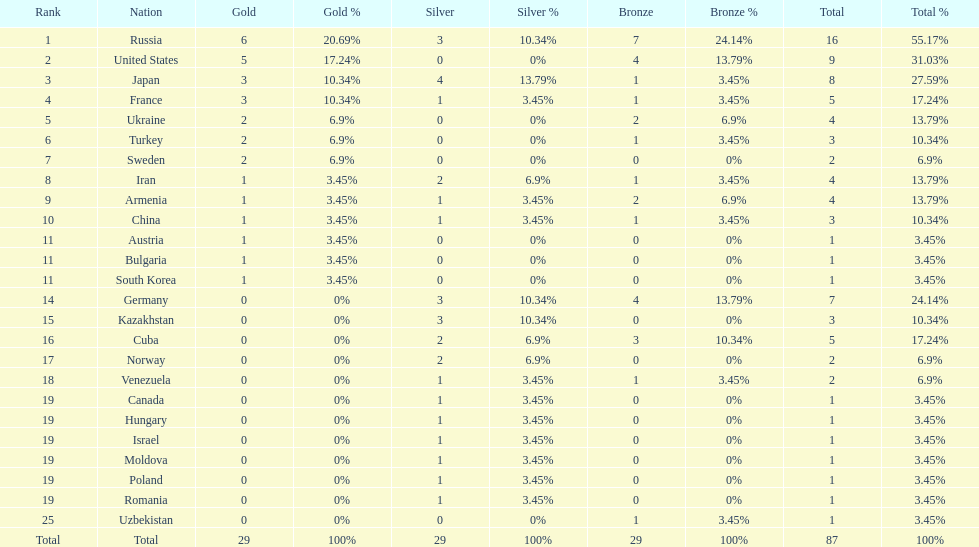Which nation was not in the top 10 iran or germany? Germany. 